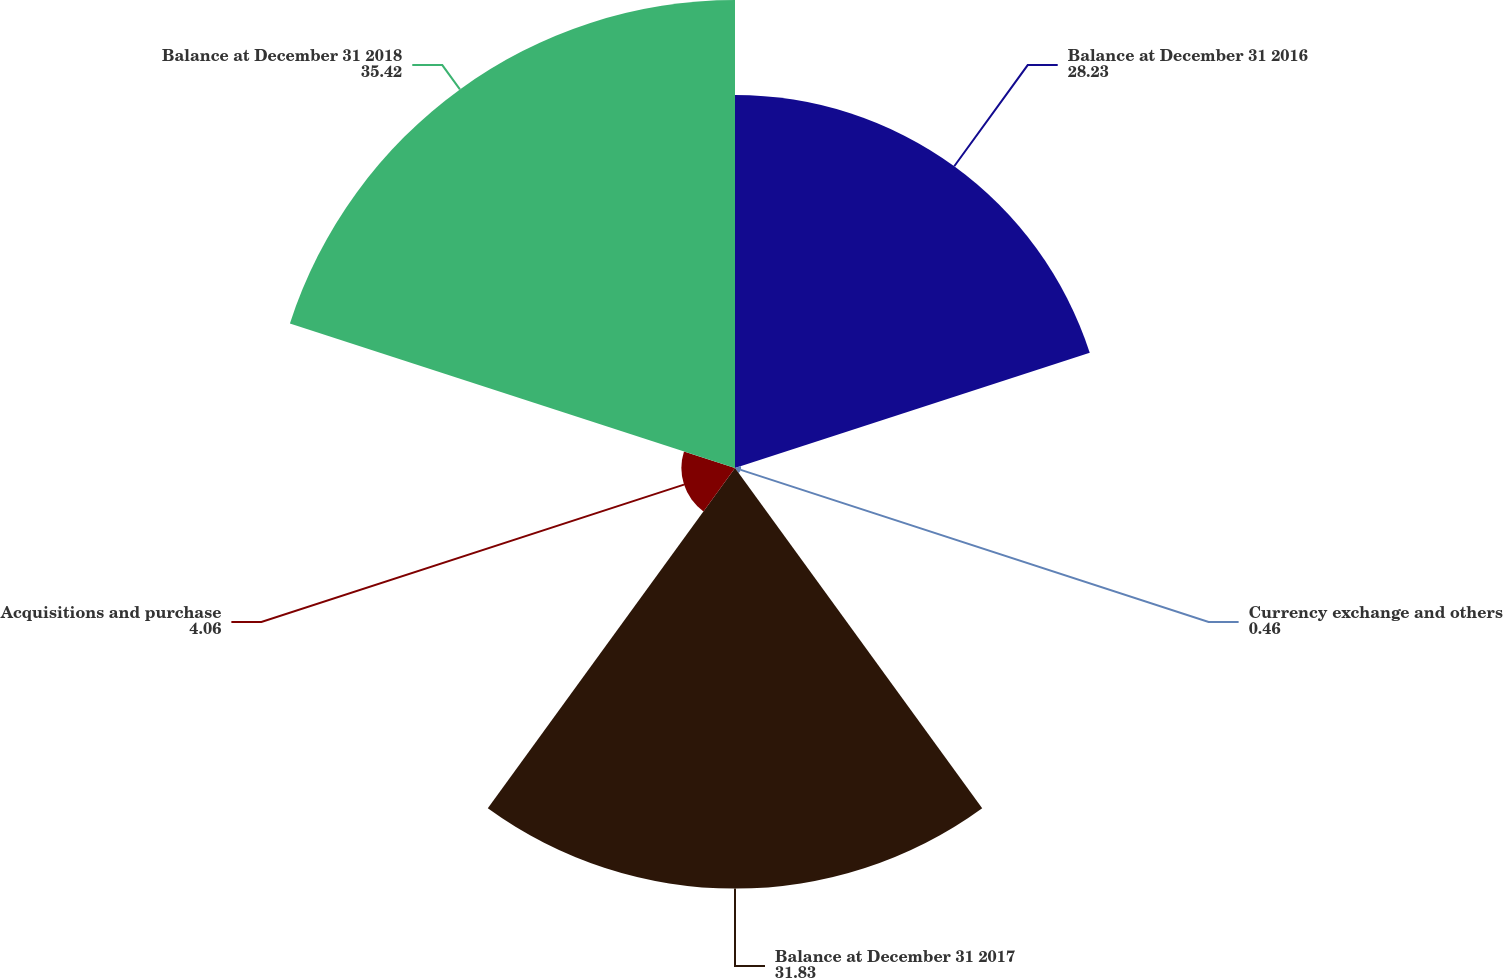Convert chart to OTSL. <chart><loc_0><loc_0><loc_500><loc_500><pie_chart><fcel>Balance at December 31 2016<fcel>Currency exchange and others<fcel>Balance at December 31 2017<fcel>Acquisitions and purchase<fcel>Balance at December 31 2018<nl><fcel>28.23%<fcel>0.46%<fcel>31.83%<fcel>4.06%<fcel>35.42%<nl></chart> 